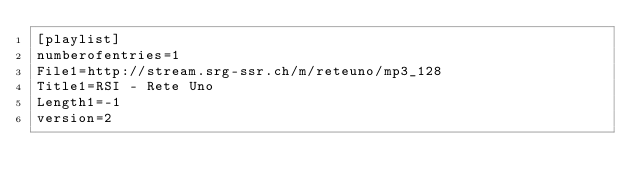<code> <loc_0><loc_0><loc_500><loc_500><_SQL_>[playlist]
numberofentries=1
File1=http://stream.srg-ssr.ch/m/reteuno/mp3_128
Title1=RSI - Rete Uno
Length1=-1
version=2
</code> 